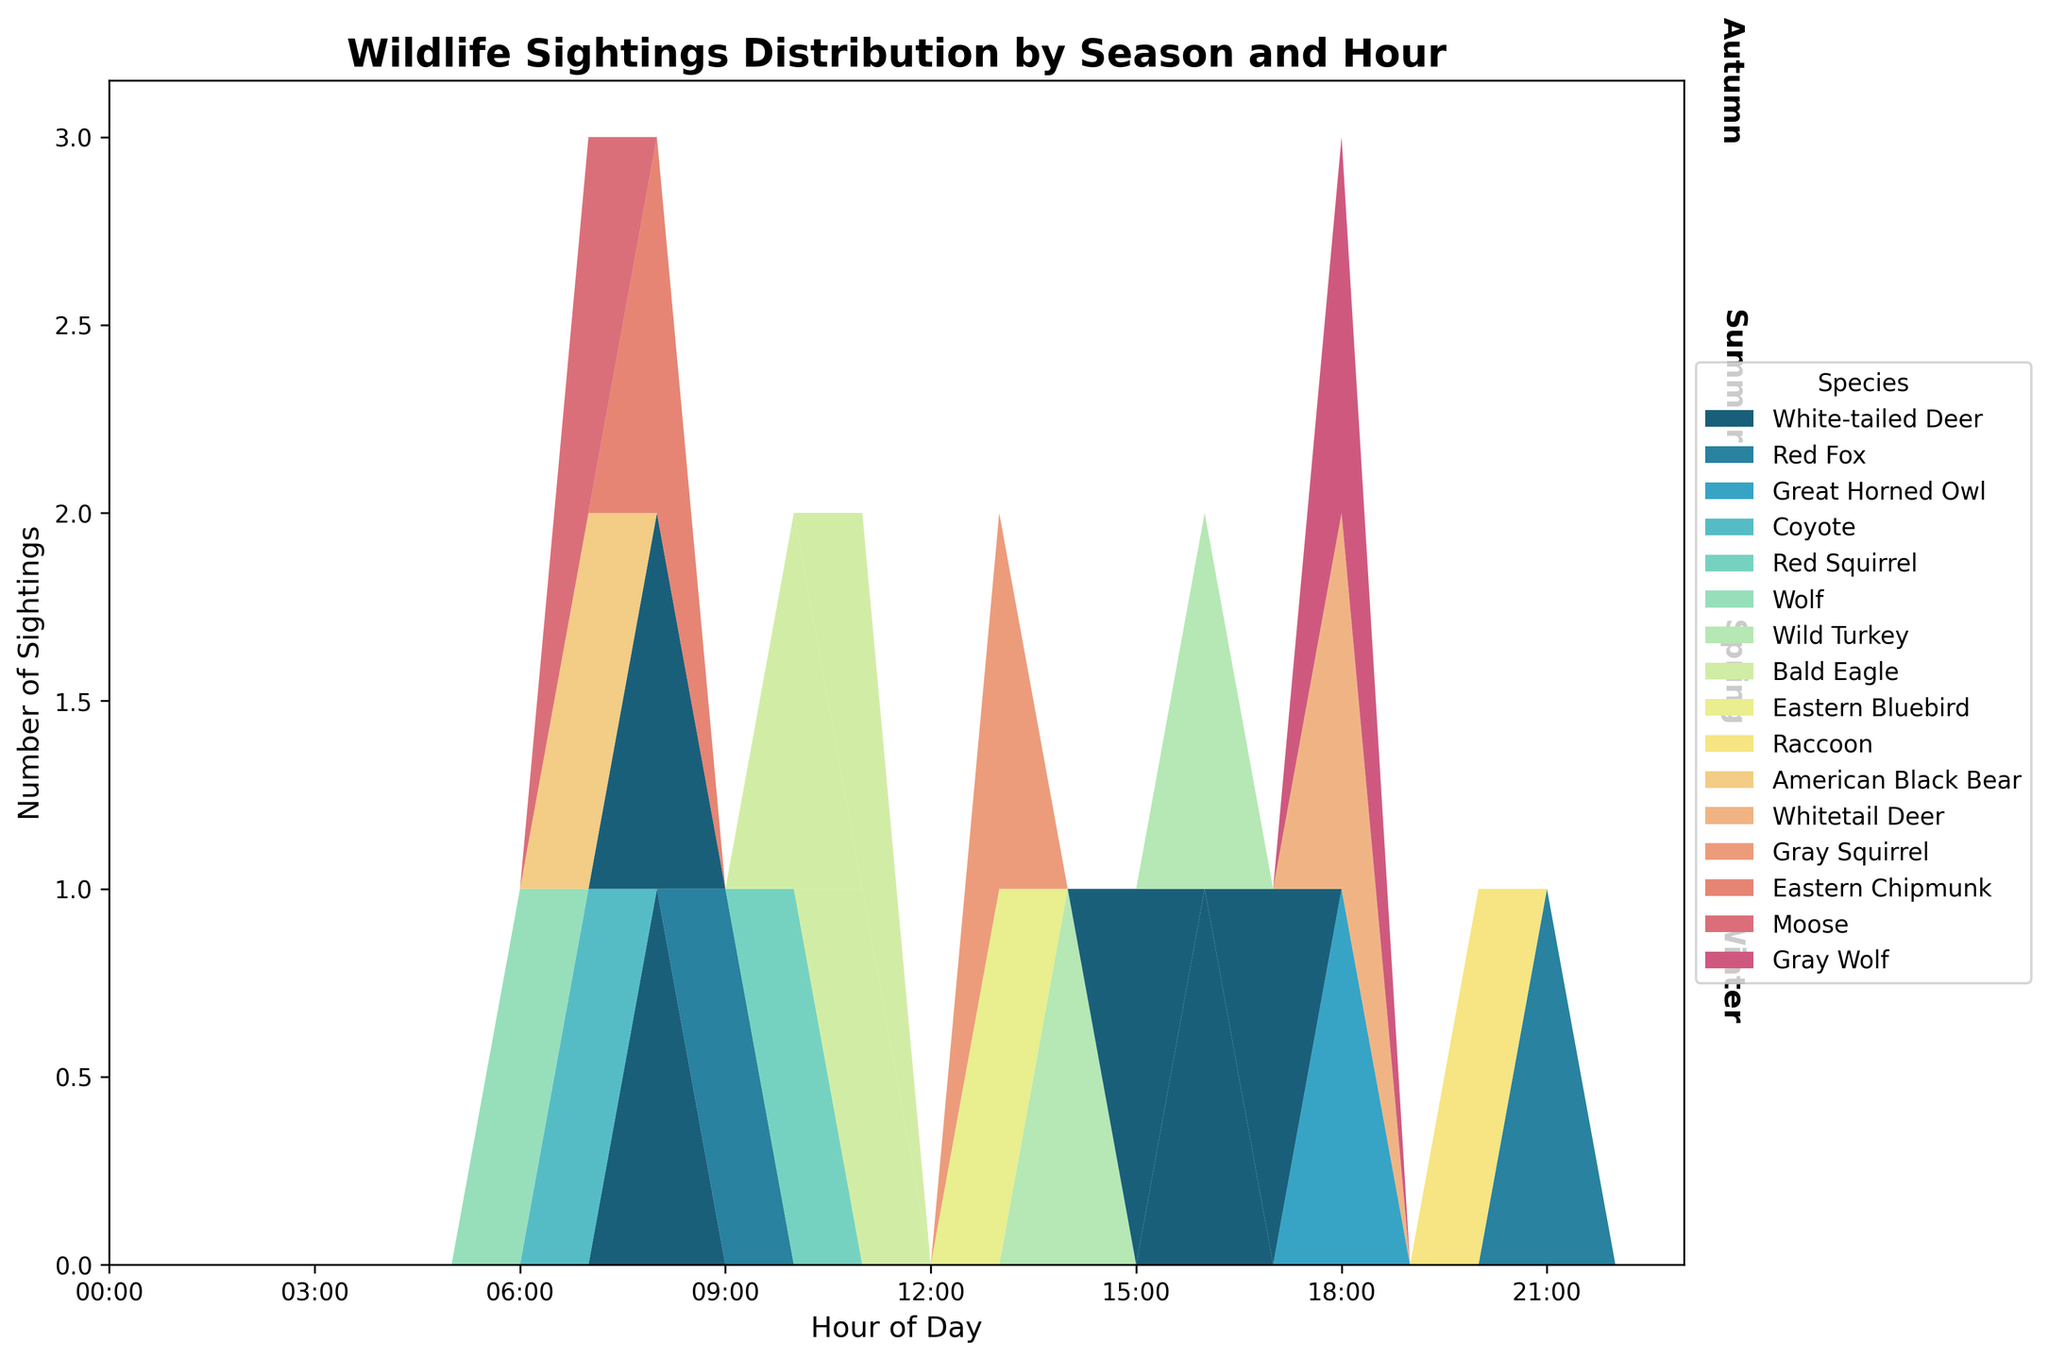What is the title of the figure? The title of the figure is located at the top and it provides an overview of the figure's content. It reads "Wildlife Sightings Distribution by Season and Hour"
Answer: Wildlife Sightings Distribution by Season and Hour How many seasons are represented in the figure? The figure is divided into sections labeled with the seasons along the right margin. By counting these labels, you can determine the total number of seasons represented.
Answer: 4 Which species has sightings across all hours of the day? By examining the layers within the streamgraph for each species, the one that spans all hours (from 0:00 to 23:00) is being asked for.
Answer: None During which season were sightings of the Bald Eagle observed the most frequently? Examine the layers corresponding to the Bald Eagle in each seasonal section of the streamgraph. The season with the thickest layer indicating the most sightings is the answer.
Answer: Autumn In what hour were the most animals sighted in Winter? Locate the Winter section of the streamgraph and pinpoint the hour with the highest peak in the aggregate sightings layer.
Answer: 18:00 Compare the number of sightings of the White-tailed Deer in Winter and Summer. Look at the layers for White-tailed Deer in both Winter and Summer sections of the graph. Compare the total height of each layer across all hours.
Answer: More in Summer What is the total number of Red Fox sightings across all seasons? Sum the sightings of the Red Fox for each season by adding the heights of the Red Fox layer across all hours in each section of the streamgraph.
Answer: 2 What time of the day were Coyote sightings recorded? Identify the layer corresponding to the Coyote and check the hour(s) this layer appears in the Winter section.
Answer: 07:00 Which species has the most variation in sighting times across different seasons? Assess each species' layer across all seasons and determine which has sightings spread across the widest range of hours.
Answer: White-tailed Deer At which hour does the figure show the highest number of animal sightings in total? By examining the combined height of all species layers across all seasons, identify the hour with the maximum sum of sightings.
Answer: 08:00 